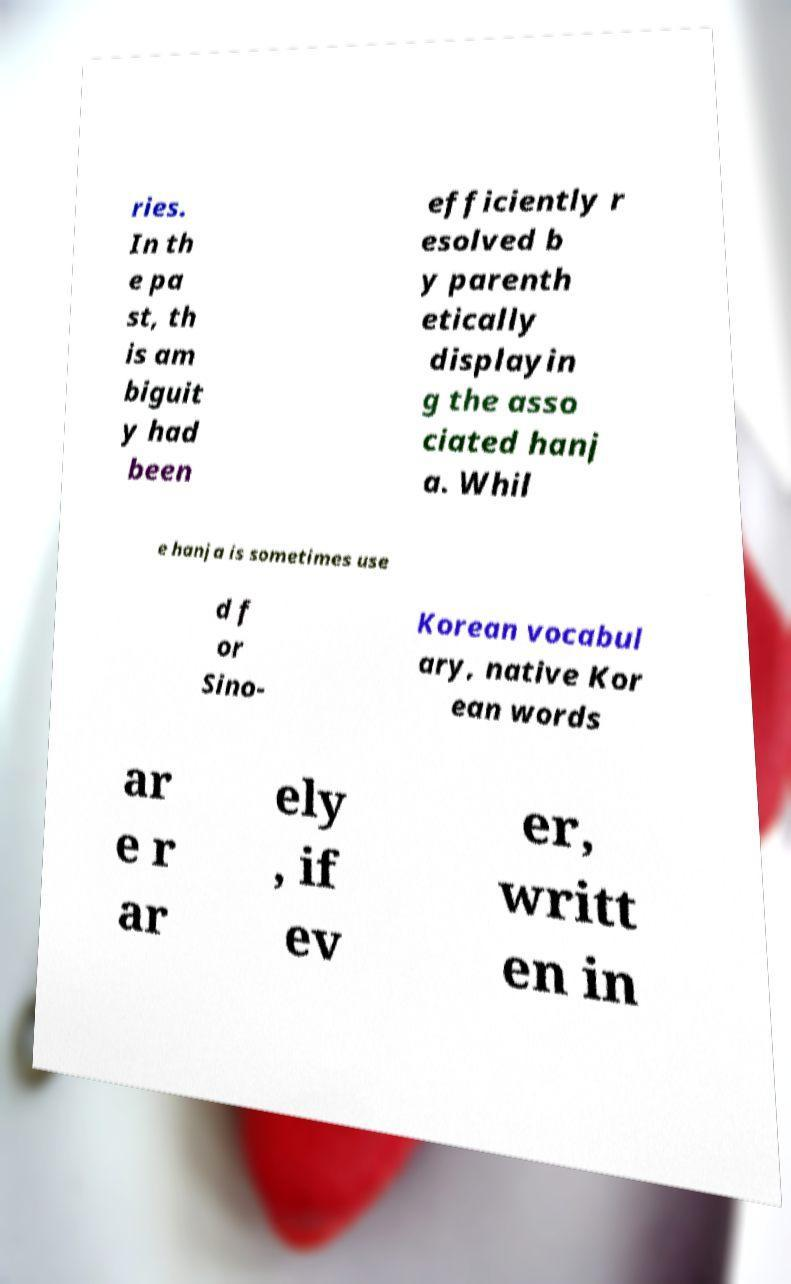I need the written content from this picture converted into text. Can you do that? ries. In th e pa st, th is am biguit y had been efficiently r esolved b y parenth etically displayin g the asso ciated hanj a. Whil e hanja is sometimes use d f or Sino- Korean vocabul ary, native Kor ean words ar e r ar ely , if ev er, writt en in 